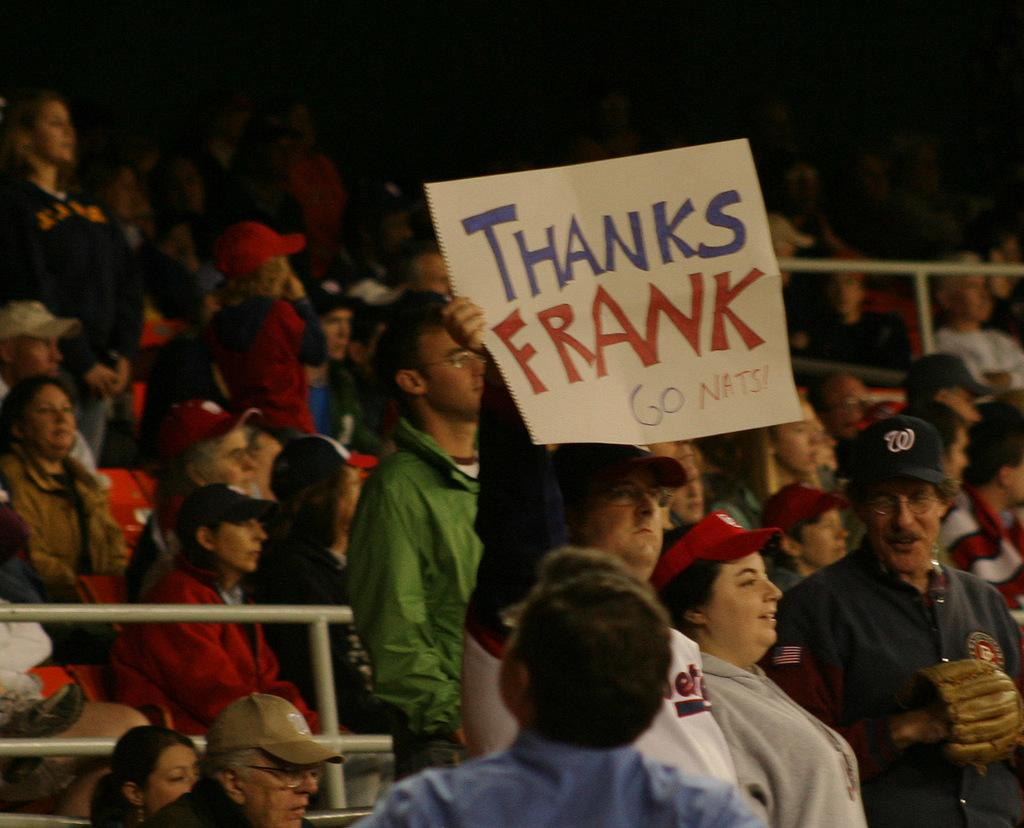How many people are in the image? There are many people in the image. What are the people in the image doing? Some people are standing, while others are sitting. A man in the middle is holding a paper with a note on it. What might the people be looking at or participating in? It appears that the people are looking at a game. What type of cake is being served to the pet in the image? There is no cake or pet present in the image. How many cubs are visible in the image? There are no cubs present in the image. 